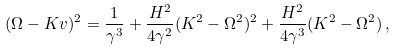Convert formula to latex. <formula><loc_0><loc_0><loc_500><loc_500>( \Omega - K v ) ^ { 2 } = \frac { 1 } { \gamma ^ { 3 } } + \frac { H ^ { 2 } } { 4 \gamma ^ { 2 } } ( K ^ { 2 } - \Omega ^ { 2 } ) ^ { 2 } + \frac { H ^ { 2 } } { 4 \gamma ^ { 3 } } ( K ^ { 2 } - \Omega ^ { 2 } ) \, ,</formula> 